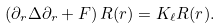<formula> <loc_0><loc_0><loc_500><loc_500>\left ( \partial _ { r } \Delta \partial _ { r } + F \right ) R ( r ) = K _ { \ell } R ( r ) .</formula> 